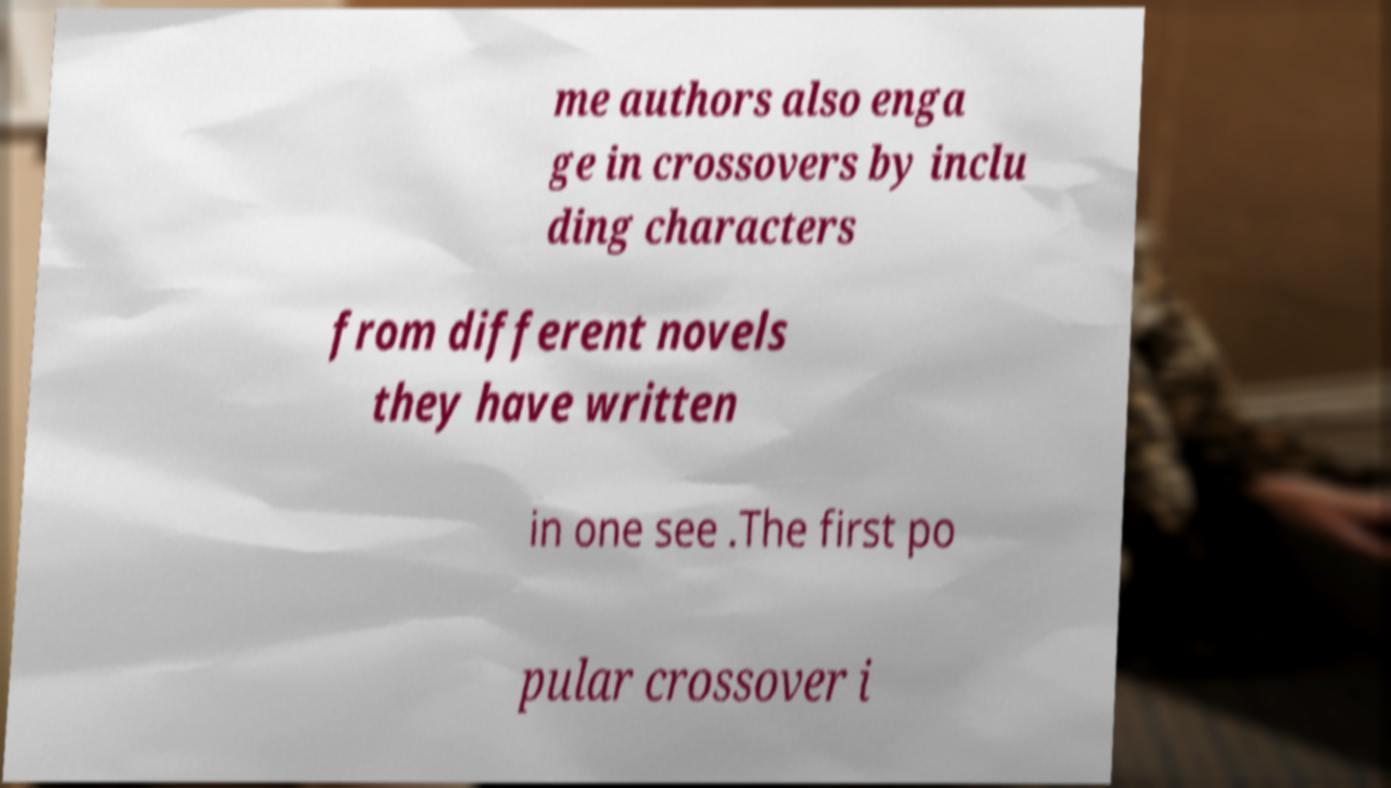I need the written content from this picture converted into text. Can you do that? me authors also enga ge in crossovers by inclu ding characters from different novels they have written in one see .The first po pular crossover i 